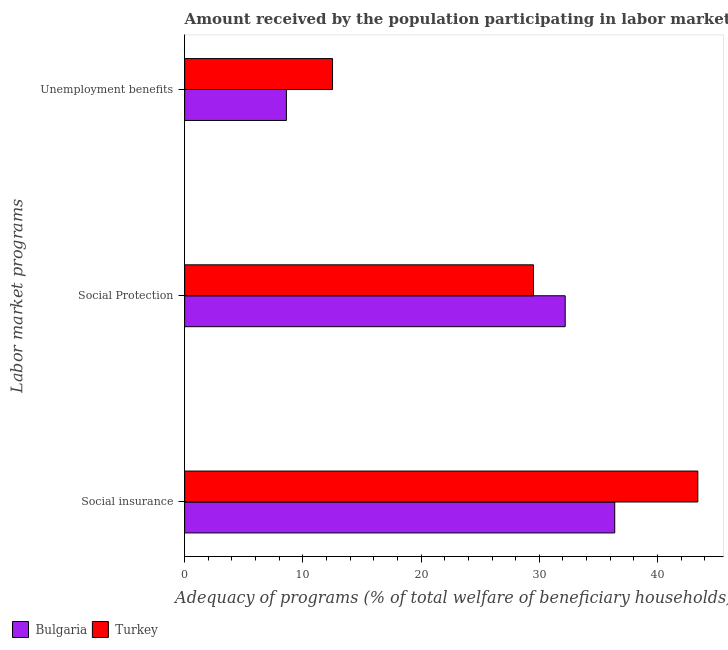How many bars are there on the 1st tick from the top?
Give a very brief answer. 2. How many bars are there on the 3rd tick from the bottom?
Offer a terse response. 2. What is the label of the 1st group of bars from the top?
Ensure brevity in your answer.  Unemployment benefits. What is the amount received by the population participating in social insurance programs in Bulgaria?
Provide a succinct answer. 36.38. Across all countries, what is the maximum amount received by the population participating in social protection programs?
Make the answer very short. 32.19. Across all countries, what is the minimum amount received by the population participating in social insurance programs?
Keep it short and to the point. 36.38. In which country was the amount received by the population participating in social protection programs minimum?
Your answer should be very brief. Turkey. What is the total amount received by the population participating in social protection programs in the graph?
Give a very brief answer. 61.7. What is the difference between the amount received by the population participating in unemployment benefits programs in Turkey and that in Bulgaria?
Keep it short and to the point. 3.9. What is the difference between the amount received by the population participating in social insurance programs in Bulgaria and the amount received by the population participating in social protection programs in Turkey?
Your answer should be very brief. 6.87. What is the average amount received by the population participating in social protection programs per country?
Give a very brief answer. 30.85. What is the difference between the amount received by the population participating in unemployment benefits programs and amount received by the population participating in social protection programs in Bulgaria?
Provide a short and direct response. -23.58. In how many countries, is the amount received by the population participating in unemployment benefits programs greater than 34 %?
Offer a very short reply. 0. What is the ratio of the amount received by the population participating in social protection programs in Bulgaria to that in Turkey?
Offer a terse response. 1.09. Is the amount received by the population participating in social protection programs in Turkey less than that in Bulgaria?
Provide a short and direct response. Yes. What is the difference between the highest and the second highest amount received by the population participating in social insurance programs?
Your answer should be very brief. 7.03. What is the difference between the highest and the lowest amount received by the population participating in social insurance programs?
Your answer should be compact. 7.03. What does the 1st bar from the bottom in Unemployment benefits represents?
Offer a terse response. Bulgaria. How many bars are there?
Your answer should be very brief. 6. Are the values on the major ticks of X-axis written in scientific E-notation?
Your answer should be very brief. No. Does the graph contain any zero values?
Keep it short and to the point. No. Where does the legend appear in the graph?
Ensure brevity in your answer.  Bottom left. How many legend labels are there?
Ensure brevity in your answer.  2. What is the title of the graph?
Your answer should be very brief. Amount received by the population participating in labor market programs in countries. Does "Myanmar" appear as one of the legend labels in the graph?
Provide a succinct answer. No. What is the label or title of the X-axis?
Provide a succinct answer. Adequacy of programs (% of total welfare of beneficiary households). What is the label or title of the Y-axis?
Offer a terse response. Labor market programs. What is the Adequacy of programs (% of total welfare of beneficiary households) in Bulgaria in Social insurance?
Give a very brief answer. 36.38. What is the Adequacy of programs (% of total welfare of beneficiary households) in Turkey in Social insurance?
Provide a succinct answer. 43.41. What is the Adequacy of programs (% of total welfare of beneficiary households) of Bulgaria in Social Protection?
Offer a very short reply. 32.19. What is the Adequacy of programs (% of total welfare of beneficiary households) of Turkey in Social Protection?
Make the answer very short. 29.51. What is the Adequacy of programs (% of total welfare of beneficiary households) in Bulgaria in Unemployment benefits?
Ensure brevity in your answer.  8.61. What is the Adequacy of programs (% of total welfare of beneficiary households) of Turkey in Unemployment benefits?
Ensure brevity in your answer.  12.51. Across all Labor market programs, what is the maximum Adequacy of programs (% of total welfare of beneficiary households) of Bulgaria?
Offer a terse response. 36.38. Across all Labor market programs, what is the maximum Adequacy of programs (% of total welfare of beneficiary households) of Turkey?
Provide a succinct answer. 43.41. Across all Labor market programs, what is the minimum Adequacy of programs (% of total welfare of beneficiary households) in Bulgaria?
Keep it short and to the point. 8.61. Across all Labor market programs, what is the minimum Adequacy of programs (% of total welfare of beneficiary households) in Turkey?
Give a very brief answer. 12.51. What is the total Adequacy of programs (% of total welfare of beneficiary households) of Bulgaria in the graph?
Your answer should be compact. 77.18. What is the total Adequacy of programs (% of total welfare of beneficiary households) in Turkey in the graph?
Your response must be concise. 85.43. What is the difference between the Adequacy of programs (% of total welfare of beneficiary households) in Bulgaria in Social insurance and that in Social Protection?
Offer a terse response. 4.19. What is the difference between the Adequacy of programs (% of total welfare of beneficiary households) in Turkey in Social insurance and that in Social Protection?
Your answer should be compact. 13.9. What is the difference between the Adequacy of programs (% of total welfare of beneficiary households) in Bulgaria in Social insurance and that in Unemployment benefits?
Give a very brief answer. 27.77. What is the difference between the Adequacy of programs (% of total welfare of beneficiary households) of Turkey in Social insurance and that in Unemployment benefits?
Your answer should be compact. 30.9. What is the difference between the Adequacy of programs (% of total welfare of beneficiary households) in Bulgaria in Social Protection and that in Unemployment benefits?
Offer a very short reply. 23.58. What is the difference between the Adequacy of programs (% of total welfare of beneficiary households) of Turkey in Social Protection and that in Unemployment benefits?
Offer a very short reply. 17. What is the difference between the Adequacy of programs (% of total welfare of beneficiary households) of Bulgaria in Social insurance and the Adequacy of programs (% of total welfare of beneficiary households) of Turkey in Social Protection?
Your answer should be very brief. 6.87. What is the difference between the Adequacy of programs (% of total welfare of beneficiary households) in Bulgaria in Social insurance and the Adequacy of programs (% of total welfare of beneficiary households) in Turkey in Unemployment benefits?
Provide a succinct answer. 23.87. What is the difference between the Adequacy of programs (% of total welfare of beneficiary households) of Bulgaria in Social Protection and the Adequacy of programs (% of total welfare of beneficiary households) of Turkey in Unemployment benefits?
Your response must be concise. 19.68. What is the average Adequacy of programs (% of total welfare of beneficiary households) of Bulgaria per Labor market programs?
Provide a short and direct response. 25.73. What is the average Adequacy of programs (% of total welfare of beneficiary households) in Turkey per Labor market programs?
Offer a terse response. 28.48. What is the difference between the Adequacy of programs (% of total welfare of beneficiary households) of Bulgaria and Adequacy of programs (% of total welfare of beneficiary households) of Turkey in Social insurance?
Offer a very short reply. -7.03. What is the difference between the Adequacy of programs (% of total welfare of beneficiary households) of Bulgaria and Adequacy of programs (% of total welfare of beneficiary households) of Turkey in Social Protection?
Your answer should be very brief. 2.68. What is the difference between the Adequacy of programs (% of total welfare of beneficiary households) in Bulgaria and Adequacy of programs (% of total welfare of beneficiary households) in Turkey in Unemployment benefits?
Provide a short and direct response. -3.9. What is the ratio of the Adequacy of programs (% of total welfare of beneficiary households) of Bulgaria in Social insurance to that in Social Protection?
Provide a succinct answer. 1.13. What is the ratio of the Adequacy of programs (% of total welfare of beneficiary households) of Turkey in Social insurance to that in Social Protection?
Provide a succinct answer. 1.47. What is the ratio of the Adequacy of programs (% of total welfare of beneficiary households) in Bulgaria in Social insurance to that in Unemployment benefits?
Your answer should be very brief. 4.23. What is the ratio of the Adequacy of programs (% of total welfare of beneficiary households) of Turkey in Social insurance to that in Unemployment benefits?
Provide a short and direct response. 3.47. What is the ratio of the Adequacy of programs (% of total welfare of beneficiary households) in Bulgaria in Social Protection to that in Unemployment benefits?
Ensure brevity in your answer.  3.74. What is the ratio of the Adequacy of programs (% of total welfare of beneficiary households) in Turkey in Social Protection to that in Unemployment benefits?
Provide a short and direct response. 2.36. What is the difference between the highest and the second highest Adequacy of programs (% of total welfare of beneficiary households) of Bulgaria?
Provide a short and direct response. 4.19. What is the difference between the highest and the second highest Adequacy of programs (% of total welfare of beneficiary households) of Turkey?
Your answer should be very brief. 13.9. What is the difference between the highest and the lowest Adequacy of programs (% of total welfare of beneficiary households) of Bulgaria?
Offer a terse response. 27.77. What is the difference between the highest and the lowest Adequacy of programs (% of total welfare of beneficiary households) in Turkey?
Offer a very short reply. 30.9. 